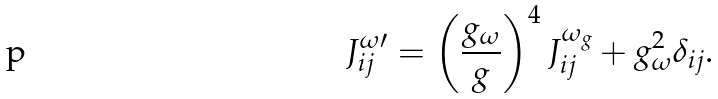Convert formula to latex. <formula><loc_0><loc_0><loc_500><loc_500>J ^ { \omega \prime } _ { i j } = \left ( \frac { g _ { \omega } } { g } \right ) ^ { 4 } J ^ { \omega _ { g } } _ { i j } + g _ { \omega } ^ { 2 } \delta _ { i j } .</formula> 